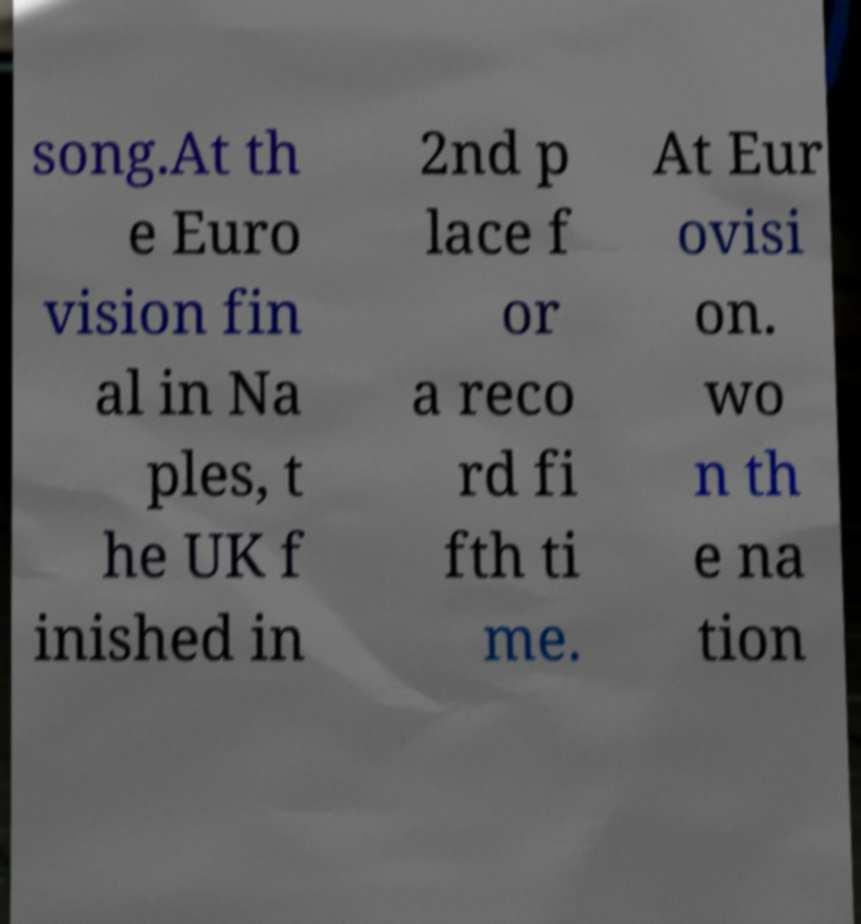For documentation purposes, I need the text within this image transcribed. Could you provide that? song.At th e Euro vision fin al in Na ples, t he UK f inished in 2nd p lace f or a reco rd fi fth ti me. At Eur ovisi on. wo n th e na tion 